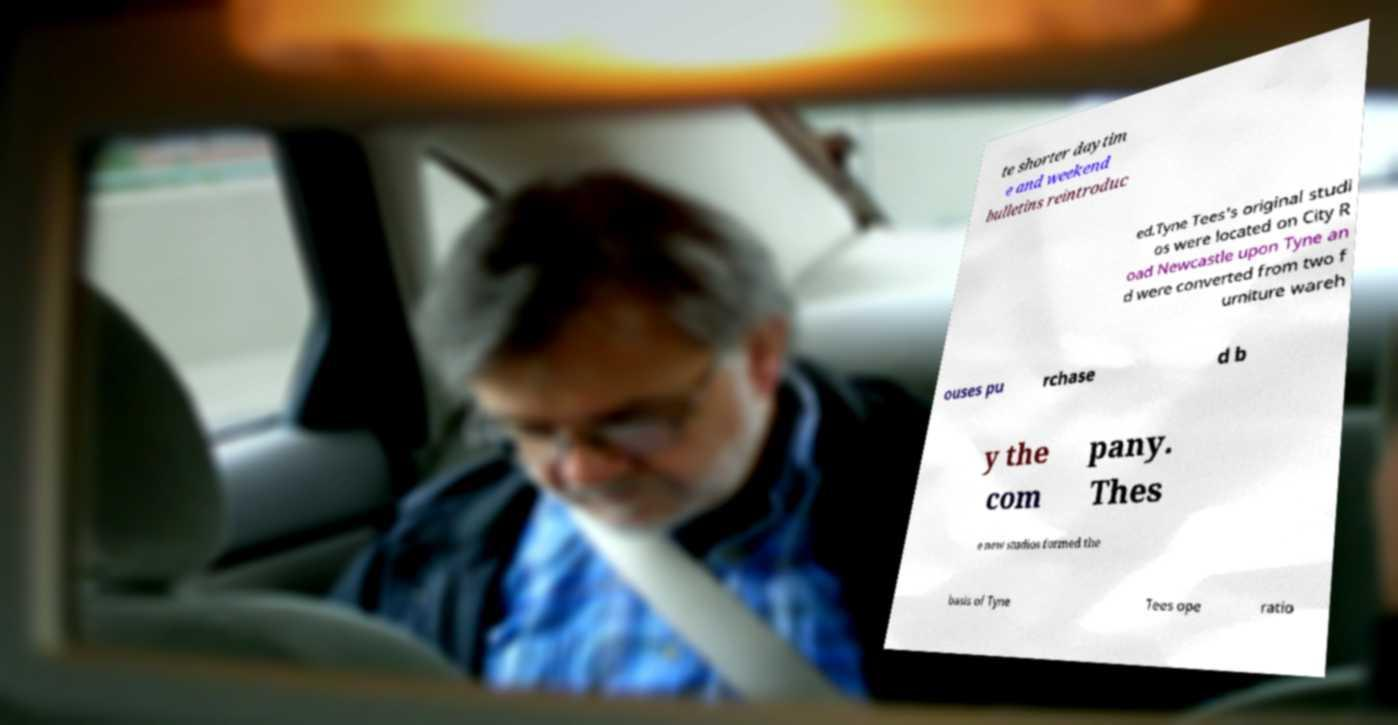For documentation purposes, I need the text within this image transcribed. Could you provide that? te shorter daytim e and weekend bulletins reintroduc ed.Tyne Tees's original studi os were located on City R oad Newcastle upon Tyne an d were converted from two f urniture wareh ouses pu rchase d b y the com pany. Thes e new studios formed the basis of Tyne Tees ope ratio 